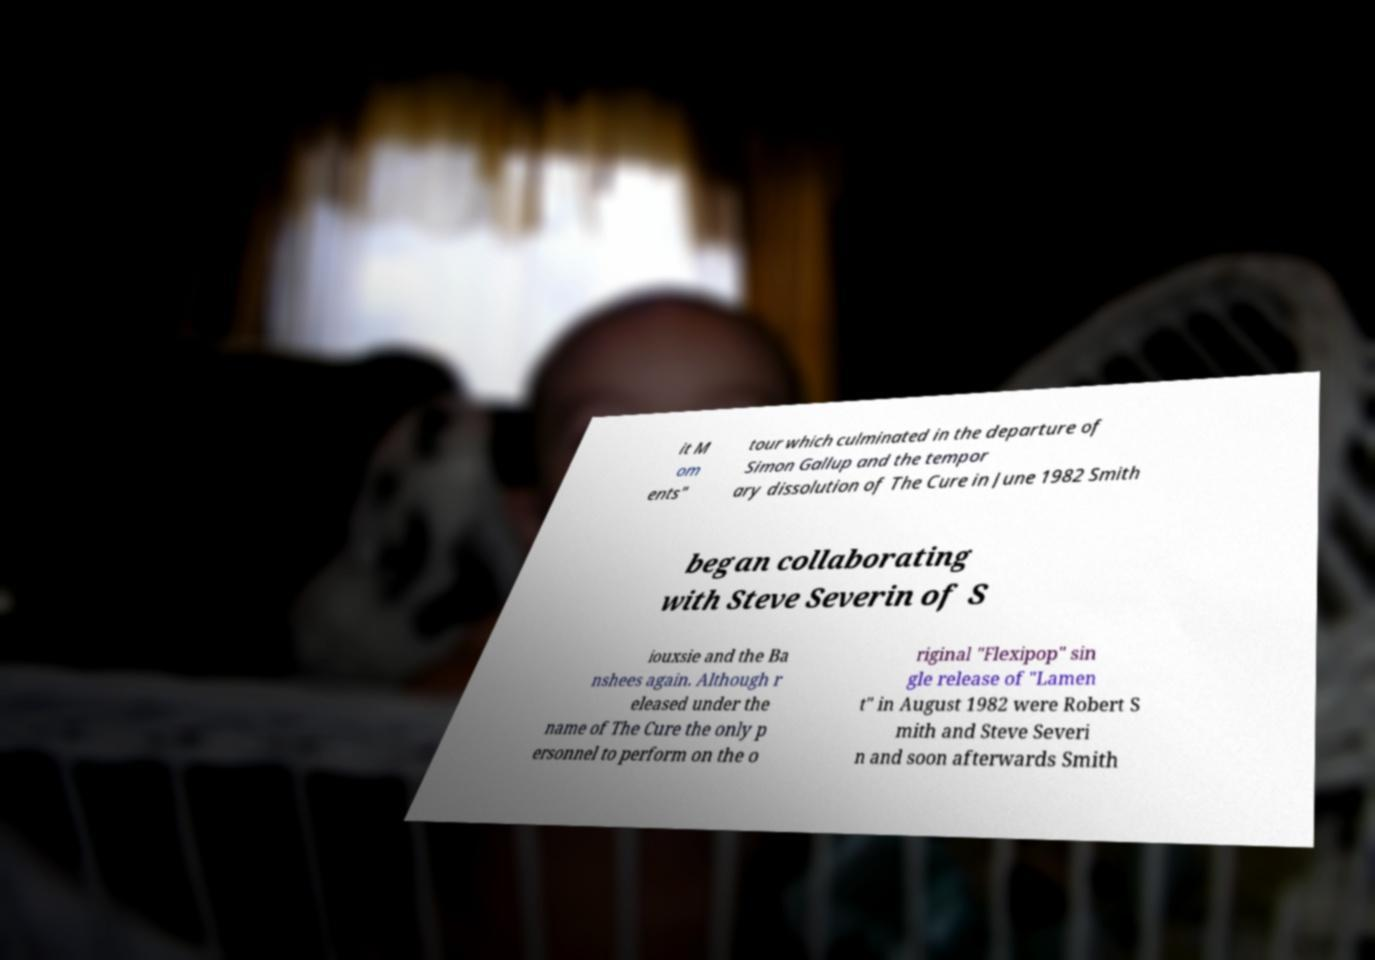Could you extract and type out the text from this image? it M om ents" tour which culminated in the departure of Simon Gallup and the tempor ary dissolution of The Cure in June 1982 Smith began collaborating with Steve Severin of S iouxsie and the Ba nshees again. Although r eleased under the name of The Cure the only p ersonnel to perform on the o riginal "Flexipop" sin gle release of "Lamen t" in August 1982 were Robert S mith and Steve Severi n and soon afterwards Smith 